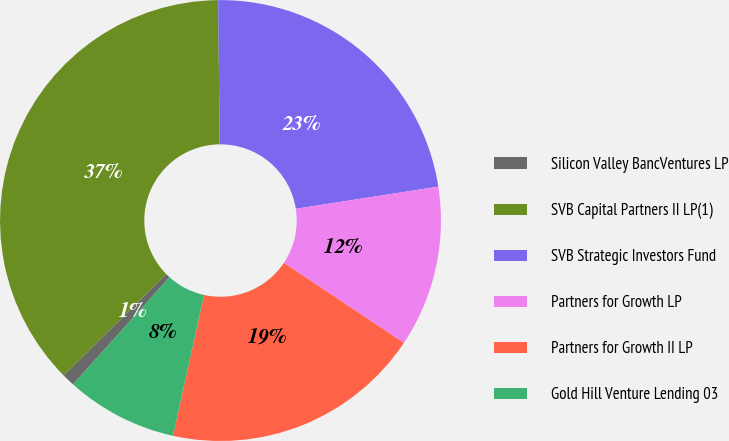Convert chart to OTSL. <chart><loc_0><loc_0><loc_500><loc_500><pie_chart><fcel>Silicon Valley BancVentures LP<fcel>SVB Capital Partners II LP(1)<fcel>SVB Strategic Investors Fund<fcel>Partners for Growth LP<fcel>Partners for Growth II LP<fcel>Gold Hill Venture Lending 03<nl><fcel>0.94%<fcel>37.23%<fcel>22.71%<fcel>11.83%<fcel>19.09%<fcel>8.2%<nl></chart> 